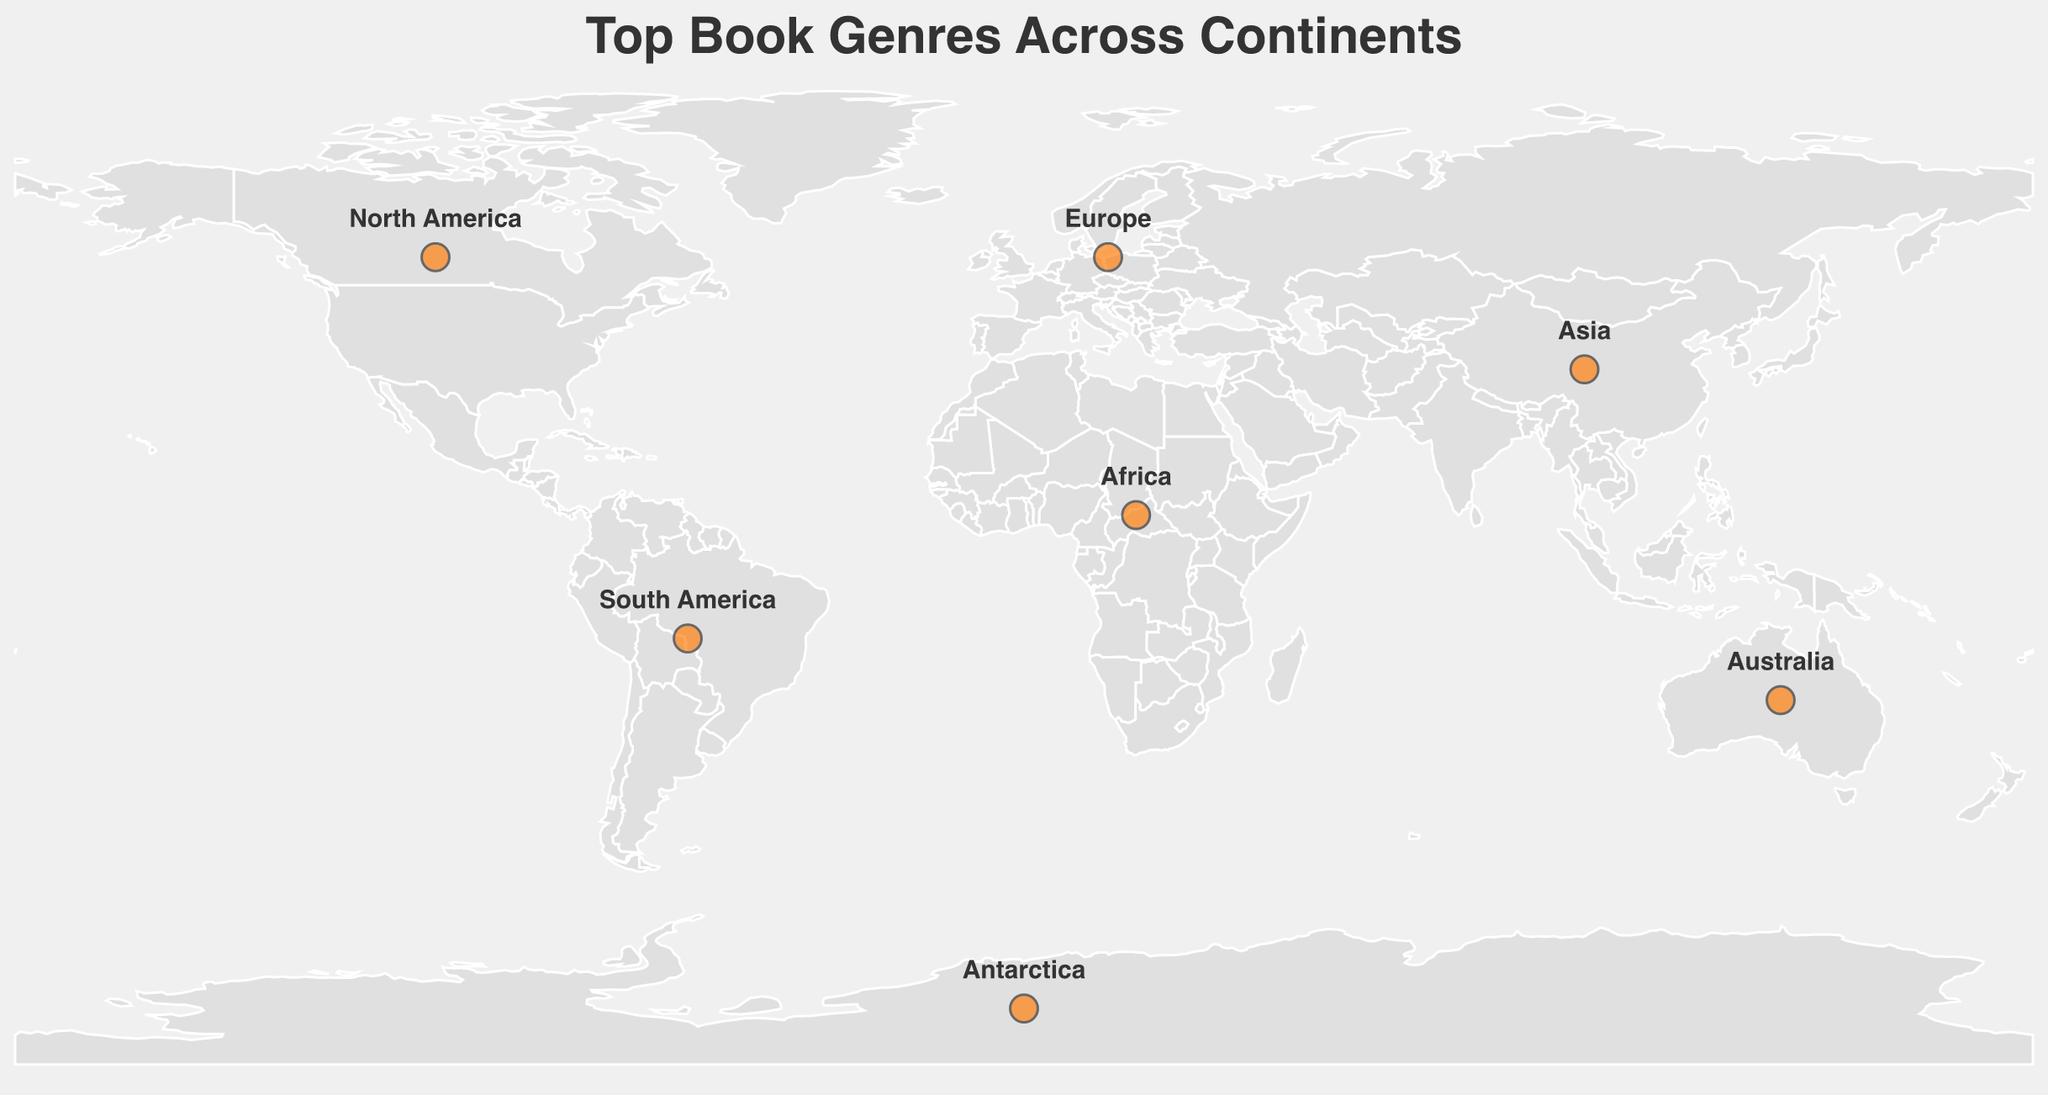what is the top genre in Europe? The figure shows that the top genre in Europe is labeled as "Mystery"
Answer: Mystery Which continent has Fantasy as the top genre? According to the figure, Asia is the continent where "Fantasy" is labeled as the top genre.
Answer: Asia Name all the top genres listed for South America. The figure indicates that the top genres for South America are "Magical Realism", "Historical Fiction", and "Self-Help".
Answer: Magical Realism, Historical Fiction, Self-Help How many continents have Mystery as one of their top genres? The figure marks Europe as the only continent where "Mystery" appears as a top genre. All continents and their top genres should be reviewed to make sure no other continent lists Mystery.
Answer: 1 Compare the top genres between Australia and North America. Which genres are unique to each of them? North America's top genres are "Thriller", "Romance", and "Science Fiction", while Australia's top genres are "Crime", "Young Adult", and "Nature Writing". The unique genres in North America are "Thriller", "Romance", and "Science Fiction". The unique genres in Australia are "Crime", "Young Adult", and "Nature Writing".
Answer: North America's unique genres: Thriller, Romance, Science Fiction. Australia's unique genres: Crime, Young Adult, Nature Writing What are the top three genres in Antarctica? The figure labels "Travel", "Science", and "Adventure" as the top three genres in Antarctica.
Answer: Travel, Science, Adventure Which continent lists Business as one of its top genres? Asia is marked with "Business" as one of its top genres as per the figure.
Answer: Asia What is the second top genre in Africa? The figure shows that the second top genre in Africa is labeled as "Political Non-Fiction".
Answer: Political Non-Fiction State the main similarity between the top genres of South America and Africa. Both South America and Africa have genres related to culture and societal themes; South America has "Magical Realism" and "Historical Fiction", and Africa has "Contemporary Fiction" and "Political Non-Fiction". These genres broadly relate to cultural and societal themes.
Answer: Cultural and societal themes 